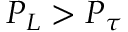<formula> <loc_0><loc_0><loc_500><loc_500>P _ { L } > P _ { \tau }</formula> 